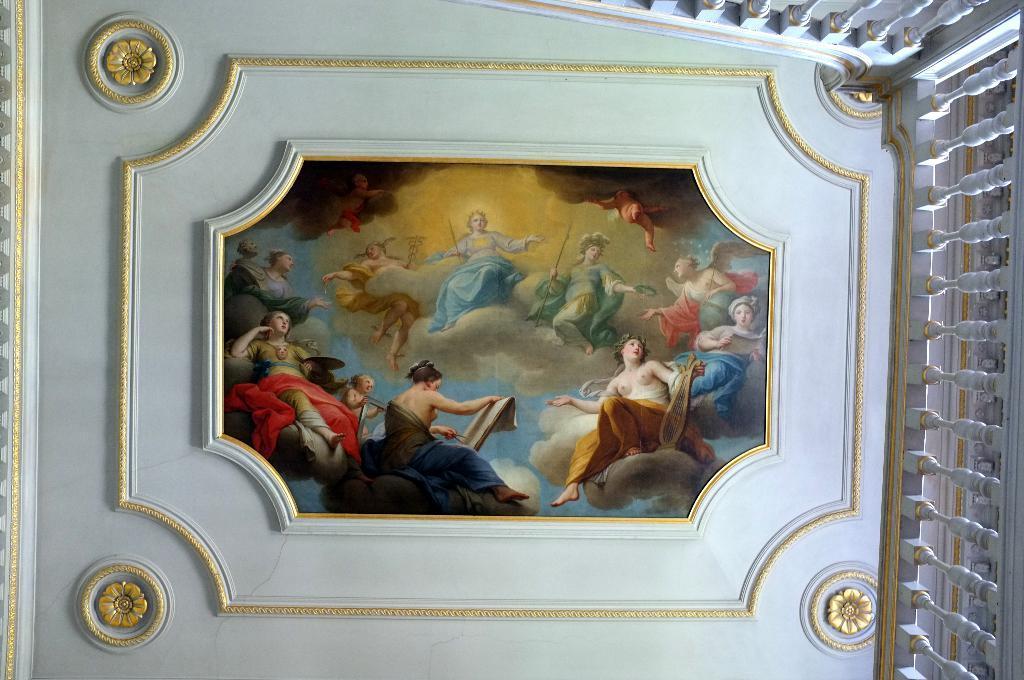In one or two sentences, can you explain what this image depicts? In the image it seems like a roof and at the centre of the roof there is some photo and on the right side there is a railing. 